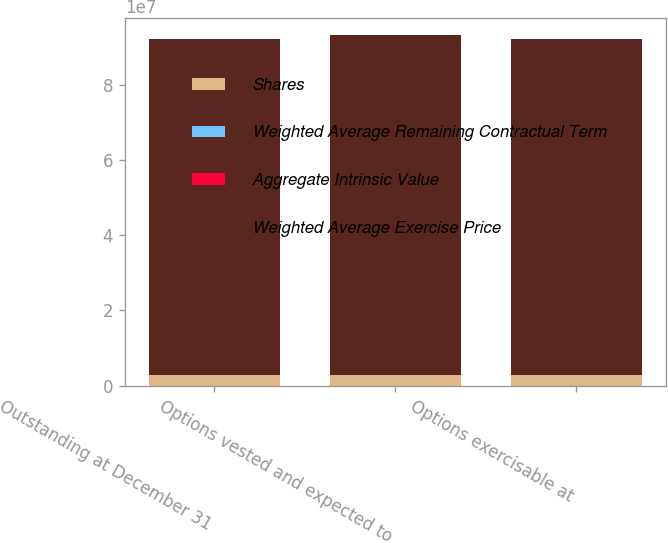Convert chart to OTSL. <chart><loc_0><loc_0><loc_500><loc_500><stacked_bar_chart><ecel><fcel>Outstanding at December 31<fcel>Options vested and expected to<fcel>Options exercisable at<nl><fcel>Shares<fcel>2.8239e+06<fcel>2.8812e+06<fcel>2.76273e+06<nl><fcel>Weighted Average Remaining Contractual Term<fcel>46.62<fcel>46.98<fcel>45.86<nl><fcel>Aggregate Intrinsic Value<fcel>2.2<fcel>2.2<fcel>2.1<nl><fcel>Weighted Average Exercise Price<fcel>8.93828e+07<fcel>9.02182e+07<fcel>8.92741e+07<nl></chart> 